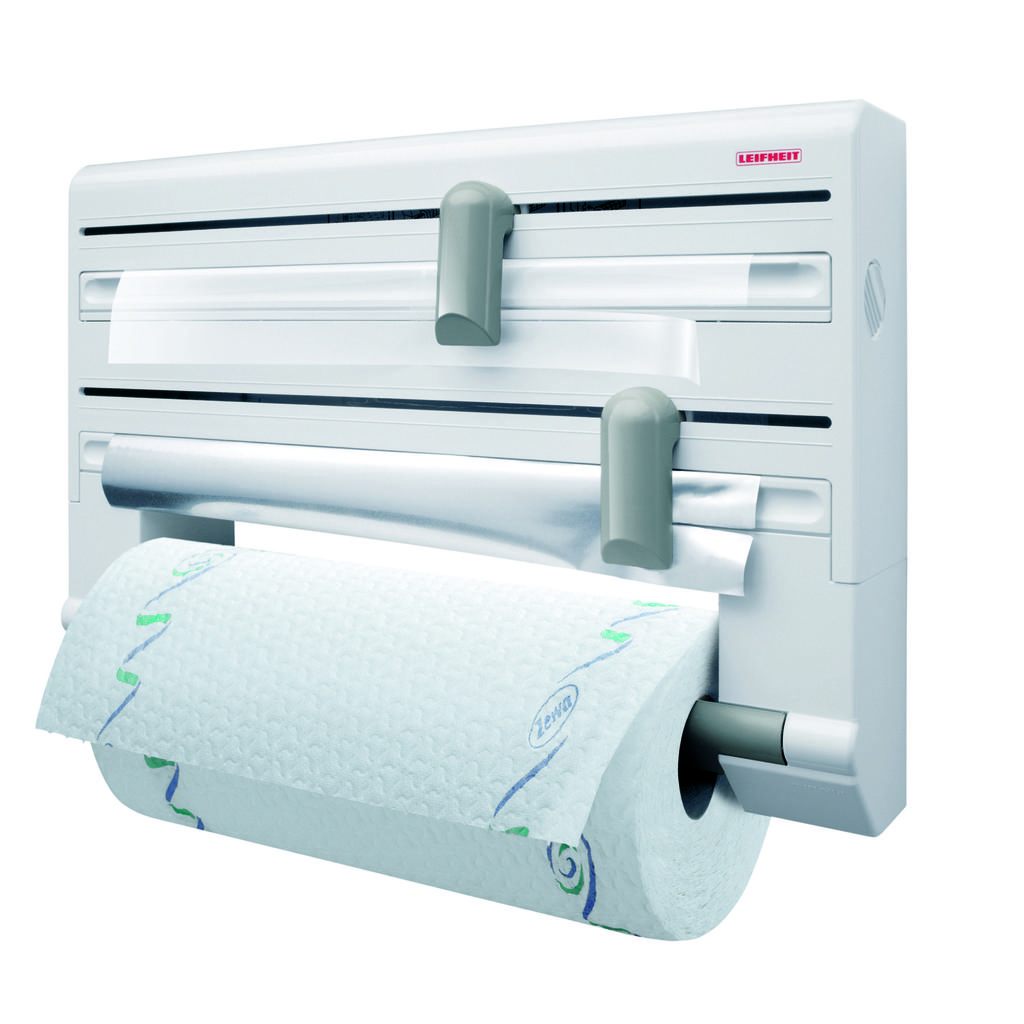What type of dispenser can be seen in the image? There is a paper towel dispenser in the image. Where is the shop located in the image? There is no shop present in the image; it only features a paper towel dispenser. What type of cannon is being used to clear the throat in the image? There is no cannon or throat-clearing activity present in the image; it only features a paper towel dispenser. 